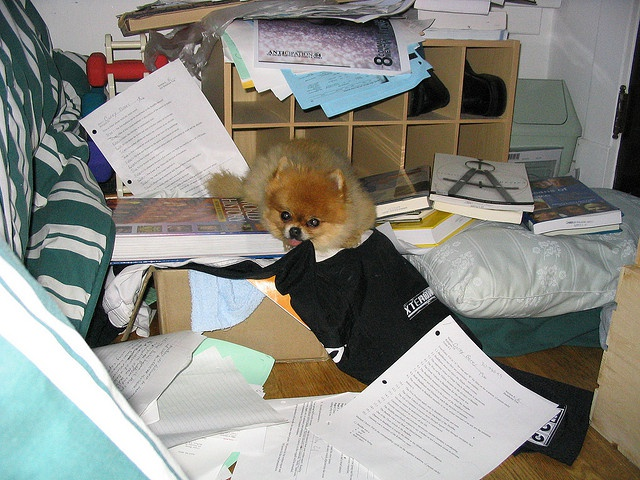Describe the objects in this image and their specific colors. I can see bed in gray, teal, darkgray, and black tones, dog in gray, olive, and tan tones, book in gray, lightgray, and darkgray tones, book in gray, darkgray, and black tones, and book in gray, black, and darkgray tones in this image. 